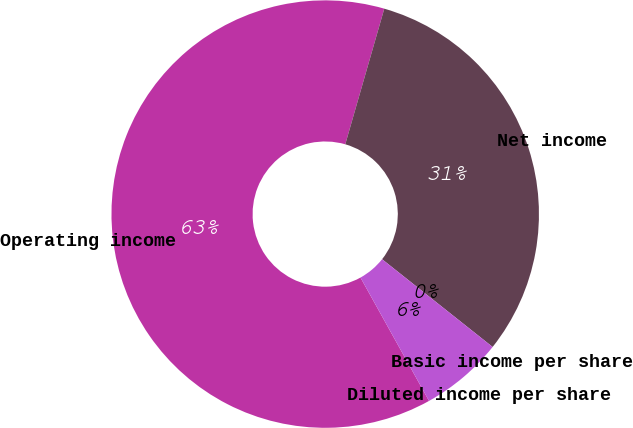<chart> <loc_0><loc_0><loc_500><loc_500><pie_chart><fcel>Operating income<fcel>Net income<fcel>Basic income per share<fcel>Diluted income per share<nl><fcel>62.53%<fcel>31.22%<fcel>0.0%<fcel>6.25%<nl></chart> 